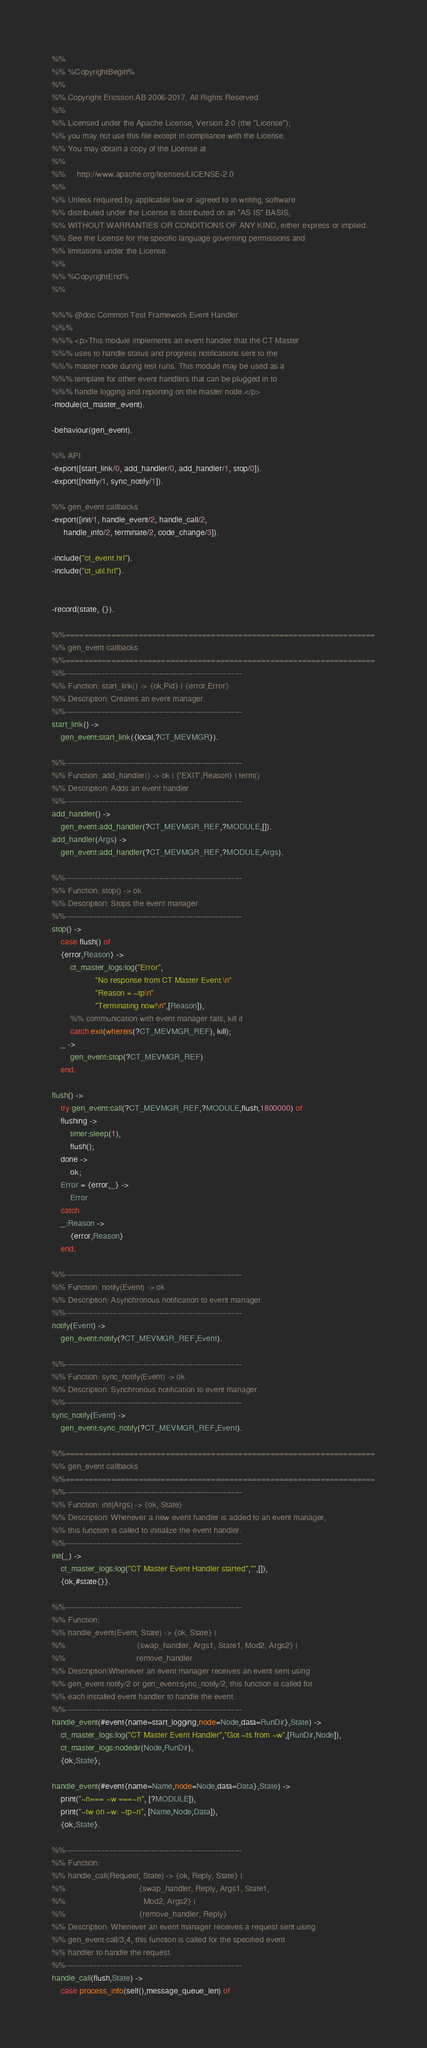<code> <loc_0><loc_0><loc_500><loc_500><_Erlang_>%%
%% %CopyrightBegin%
%% 
%% Copyright Ericsson AB 2006-2017. All Rights Reserved.
%% 
%% Licensed under the Apache License, Version 2.0 (the "License");
%% you may not use this file except in compliance with the License.
%% You may obtain a copy of the License at
%%
%%     http://www.apache.org/licenses/LICENSE-2.0
%%
%% Unless required by applicable law or agreed to in writing, software
%% distributed under the License is distributed on an "AS IS" BASIS,
%% WITHOUT WARRANTIES OR CONDITIONS OF ANY KIND, either express or implied.
%% See the License for the specific language governing permissions and
%% limitations under the License.
%% 
%% %CopyrightEnd%
%%

%%% @doc Common Test Framework Event Handler
%%%
%%% <p>This module implements an event handler that the CT Master
%%% uses to handle status and progress notifications sent to the
%%% master node during test runs. This module may be used as a 
%%% template for other event handlers that can be plugged in to 
%%% handle logging and reporting on the master node.</p>
-module(ct_master_event).

-behaviour(gen_event).

%% API
-export([start_link/0, add_handler/0, add_handler/1, stop/0]).
-export([notify/1, sync_notify/1]).

%% gen_event callbacks
-export([init/1, handle_event/2, handle_call/2, 
	 handle_info/2, terminate/2, code_change/3]).

-include("ct_event.hrl").
-include("ct_util.hrl").


-record(state, {}).

%%====================================================================
%% gen_event callbacks
%%====================================================================
%%--------------------------------------------------------------------
%% Function: start_link() -> {ok,Pid} | {error,Error} 
%% Description: Creates an event manager.
%%--------------------------------------------------------------------
start_link() ->
    gen_event:start_link({local,?CT_MEVMGR}). 

%%--------------------------------------------------------------------
%% Function: add_handler() -> ok | {'EXIT',Reason} | term()
%% Description: Adds an event handler
%%--------------------------------------------------------------------
add_handler() ->
    gen_event:add_handler(?CT_MEVMGR_REF,?MODULE,[]).
add_handler(Args) ->
    gen_event:add_handler(?CT_MEVMGR_REF,?MODULE,Args).

%%--------------------------------------------------------------------
%% Function: stop() -> ok
%% Description: Stops the event manager
%%--------------------------------------------------------------------
stop() ->
    case flush() of
	{error,Reason} ->
	    ct_master_logs:log("Error",
			       "No response from CT Master Event.\n"
			       "Reason = ~tp\n"
			       "Terminating now!\n",[Reason]),
	    %% communication with event manager fails, kill it
	    catch exit(whereis(?CT_MEVMGR_REF), kill);
	_ ->
	    gen_event:stop(?CT_MEVMGR_REF)
    end.

flush() ->
    try gen_event:call(?CT_MEVMGR_REF,?MODULE,flush,1800000) of
	flushing ->
	    timer:sleep(1),
	    flush();
	done ->
	    ok;
	Error = {error,_} ->
	    Error
    catch
	_:Reason ->
	    {error,Reason}
    end.

%%--------------------------------------------------------------------
%% Function: notify(Event) -> ok
%% Description: Asynchronous notification to event manager.
%%--------------------------------------------------------------------
notify(Event) ->
    gen_event:notify(?CT_MEVMGR_REF,Event).

%%--------------------------------------------------------------------
%% Function: sync_notify(Event) -> ok
%% Description: Synchronous notification to event manager.
%%--------------------------------------------------------------------
sync_notify(Event) ->
    gen_event:sync_notify(?CT_MEVMGR_REF,Event).

%%====================================================================
%% gen_event callbacks
%%====================================================================
%%--------------------------------------------------------------------
%% Function: init(Args) -> {ok, State}
%% Description: Whenever a new event handler is added to an event manager,
%% this function is called to initialize the event handler.
%%--------------------------------------------------------------------
init(_) ->
    ct_master_logs:log("CT Master Event Handler started","",[]),
    {ok,#state{}}.

%%--------------------------------------------------------------------
%% Function:  
%% handle_event(Event, State) -> {ok, State} |
%%                               {swap_handler, Args1, State1, Mod2, Args2} |
%%                               remove_handler
%% Description:Whenever an event manager receives an event sent using
%% gen_event:notify/2 or gen_event:sync_notify/2, this function is called for
%% each installed event handler to handle the event. 
%%--------------------------------------------------------------------
handle_event(#event{name=start_logging,node=Node,data=RunDir},State) ->
    ct_master_logs:log("CT Master Event Handler","Got ~ts from ~w",[RunDir,Node]),
    ct_master_logs:nodedir(Node,RunDir),
    {ok,State};

handle_event(#event{name=Name,node=Node,data=Data},State) ->
    print("~n=== ~w ===~n", [?MODULE]),
    print("~tw on ~w: ~tp~n", [Name,Node,Data]),
    {ok,State}.

%%--------------------------------------------------------------------
%% Function: 
%% handle_call(Request, State) -> {ok, Reply, State} |
%%                                {swap_handler, Reply, Args1, State1, 
%%                                  Mod2, Args2} |
%%                                {remove_handler, Reply}
%% Description: Whenever an event manager receives a request sent using
%% gen_event:call/3,4, this function is called for the specified event 
%% handler to handle the request.
%%--------------------------------------------------------------------
handle_call(flush,State) ->
    case process_info(self(),message_queue_len) of</code> 